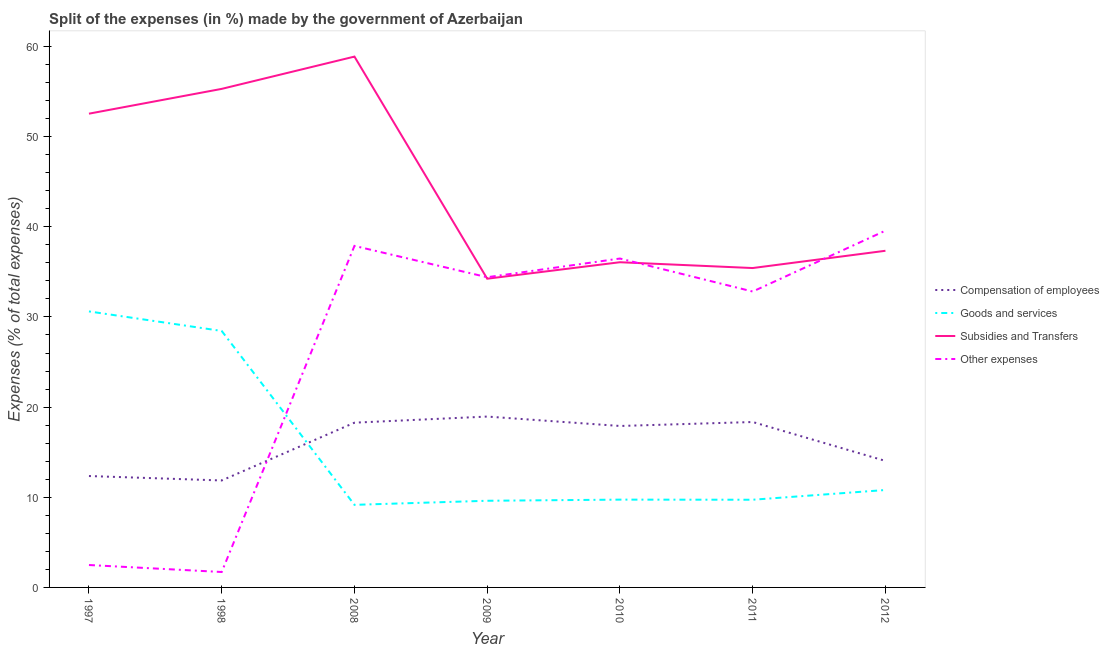How many different coloured lines are there?
Provide a succinct answer. 4. Does the line corresponding to percentage of amount spent on compensation of employees intersect with the line corresponding to percentage of amount spent on goods and services?
Provide a succinct answer. Yes. Is the number of lines equal to the number of legend labels?
Give a very brief answer. Yes. What is the percentage of amount spent on other expenses in 1997?
Offer a very short reply. 2.49. Across all years, what is the maximum percentage of amount spent on goods and services?
Offer a terse response. 30.62. Across all years, what is the minimum percentage of amount spent on goods and services?
Make the answer very short. 9.16. What is the total percentage of amount spent on other expenses in the graph?
Offer a terse response. 185.36. What is the difference between the percentage of amount spent on subsidies in 1998 and that in 2011?
Your answer should be very brief. 19.87. What is the difference between the percentage of amount spent on subsidies in 2011 and the percentage of amount spent on compensation of employees in 2012?
Keep it short and to the point. 21.39. What is the average percentage of amount spent on subsidies per year?
Give a very brief answer. 44.26. In the year 2011, what is the difference between the percentage of amount spent on goods and services and percentage of amount spent on subsidies?
Make the answer very short. -25.7. What is the ratio of the percentage of amount spent on goods and services in 2011 to that in 2012?
Your answer should be very brief. 0.9. Is the difference between the percentage of amount spent on subsidies in 1998 and 2010 greater than the difference between the percentage of amount spent on other expenses in 1998 and 2010?
Provide a succinct answer. Yes. What is the difference between the highest and the second highest percentage of amount spent on subsidies?
Offer a very short reply. 3.58. What is the difference between the highest and the lowest percentage of amount spent on subsidies?
Make the answer very short. 24.64. Is it the case that in every year, the sum of the percentage of amount spent on goods and services and percentage of amount spent on subsidies is greater than the sum of percentage of amount spent on compensation of employees and percentage of amount spent on other expenses?
Provide a succinct answer. Yes. How many lines are there?
Provide a succinct answer. 4. How many years are there in the graph?
Your response must be concise. 7. How many legend labels are there?
Your answer should be very brief. 4. How are the legend labels stacked?
Provide a short and direct response. Vertical. What is the title of the graph?
Make the answer very short. Split of the expenses (in %) made by the government of Azerbaijan. What is the label or title of the X-axis?
Provide a short and direct response. Year. What is the label or title of the Y-axis?
Keep it short and to the point. Expenses (% of total expenses). What is the Expenses (% of total expenses) of Compensation of employees in 1997?
Give a very brief answer. 12.36. What is the Expenses (% of total expenses) in Goods and services in 1997?
Offer a terse response. 30.62. What is the Expenses (% of total expenses) in Subsidies and Transfers in 1997?
Ensure brevity in your answer.  52.55. What is the Expenses (% of total expenses) in Other expenses in 1997?
Make the answer very short. 2.49. What is the Expenses (% of total expenses) in Compensation of employees in 1998?
Your answer should be very brief. 11.86. What is the Expenses (% of total expenses) in Goods and services in 1998?
Your answer should be very brief. 28.45. What is the Expenses (% of total expenses) in Subsidies and Transfers in 1998?
Your answer should be very brief. 55.3. What is the Expenses (% of total expenses) of Other expenses in 1998?
Your answer should be very brief. 1.71. What is the Expenses (% of total expenses) in Compensation of employees in 2008?
Keep it short and to the point. 18.27. What is the Expenses (% of total expenses) in Goods and services in 2008?
Keep it short and to the point. 9.16. What is the Expenses (% of total expenses) of Subsidies and Transfers in 2008?
Your answer should be compact. 58.88. What is the Expenses (% of total expenses) of Other expenses in 2008?
Offer a terse response. 37.88. What is the Expenses (% of total expenses) in Compensation of employees in 2009?
Ensure brevity in your answer.  18.95. What is the Expenses (% of total expenses) in Goods and services in 2009?
Provide a succinct answer. 9.61. What is the Expenses (% of total expenses) in Subsidies and Transfers in 2009?
Make the answer very short. 34.24. What is the Expenses (% of total expenses) of Other expenses in 2009?
Provide a succinct answer. 34.41. What is the Expenses (% of total expenses) of Compensation of employees in 2010?
Offer a terse response. 17.91. What is the Expenses (% of total expenses) in Goods and services in 2010?
Your answer should be compact. 9.74. What is the Expenses (% of total expenses) of Subsidies and Transfers in 2010?
Offer a terse response. 36.07. What is the Expenses (% of total expenses) of Other expenses in 2010?
Provide a succinct answer. 36.48. What is the Expenses (% of total expenses) in Compensation of employees in 2011?
Keep it short and to the point. 18.35. What is the Expenses (% of total expenses) in Goods and services in 2011?
Offer a very short reply. 9.73. What is the Expenses (% of total expenses) in Subsidies and Transfers in 2011?
Ensure brevity in your answer.  35.43. What is the Expenses (% of total expenses) of Other expenses in 2011?
Your answer should be compact. 32.82. What is the Expenses (% of total expenses) in Compensation of employees in 2012?
Ensure brevity in your answer.  14.03. What is the Expenses (% of total expenses) of Goods and services in 2012?
Keep it short and to the point. 10.81. What is the Expenses (% of total expenses) of Subsidies and Transfers in 2012?
Give a very brief answer. 37.34. What is the Expenses (% of total expenses) in Other expenses in 2012?
Keep it short and to the point. 39.57. Across all years, what is the maximum Expenses (% of total expenses) in Compensation of employees?
Make the answer very short. 18.95. Across all years, what is the maximum Expenses (% of total expenses) of Goods and services?
Keep it short and to the point. 30.62. Across all years, what is the maximum Expenses (% of total expenses) in Subsidies and Transfers?
Your response must be concise. 58.88. Across all years, what is the maximum Expenses (% of total expenses) in Other expenses?
Keep it short and to the point. 39.57. Across all years, what is the minimum Expenses (% of total expenses) of Compensation of employees?
Make the answer very short. 11.86. Across all years, what is the minimum Expenses (% of total expenses) in Goods and services?
Ensure brevity in your answer.  9.16. Across all years, what is the minimum Expenses (% of total expenses) of Subsidies and Transfers?
Offer a terse response. 34.24. Across all years, what is the minimum Expenses (% of total expenses) of Other expenses?
Offer a very short reply. 1.71. What is the total Expenses (% of total expenses) of Compensation of employees in the graph?
Ensure brevity in your answer.  111.74. What is the total Expenses (% of total expenses) of Goods and services in the graph?
Your response must be concise. 108.11. What is the total Expenses (% of total expenses) in Subsidies and Transfers in the graph?
Provide a succinct answer. 309.81. What is the total Expenses (% of total expenses) in Other expenses in the graph?
Your answer should be compact. 185.36. What is the difference between the Expenses (% of total expenses) of Compensation of employees in 1997 and that in 1998?
Provide a short and direct response. 0.49. What is the difference between the Expenses (% of total expenses) in Goods and services in 1997 and that in 1998?
Make the answer very short. 2.17. What is the difference between the Expenses (% of total expenses) of Subsidies and Transfers in 1997 and that in 1998?
Your response must be concise. -2.75. What is the difference between the Expenses (% of total expenses) in Other expenses in 1997 and that in 1998?
Make the answer very short. 0.77. What is the difference between the Expenses (% of total expenses) in Compensation of employees in 1997 and that in 2008?
Your answer should be compact. -5.92. What is the difference between the Expenses (% of total expenses) of Goods and services in 1997 and that in 2008?
Your answer should be compact. 21.45. What is the difference between the Expenses (% of total expenses) of Subsidies and Transfers in 1997 and that in 2008?
Provide a succinct answer. -6.33. What is the difference between the Expenses (% of total expenses) of Other expenses in 1997 and that in 2008?
Ensure brevity in your answer.  -35.4. What is the difference between the Expenses (% of total expenses) of Compensation of employees in 1997 and that in 2009?
Your response must be concise. -6.6. What is the difference between the Expenses (% of total expenses) in Goods and services in 1997 and that in 2009?
Provide a short and direct response. 21. What is the difference between the Expenses (% of total expenses) of Subsidies and Transfers in 1997 and that in 2009?
Provide a succinct answer. 18.31. What is the difference between the Expenses (% of total expenses) of Other expenses in 1997 and that in 2009?
Make the answer very short. -31.92. What is the difference between the Expenses (% of total expenses) in Compensation of employees in 1997 and that in 2010?
Your answer should be compact. -5.55. What is the difference between the Expenses (% of total expenses) in Goods and services in 1997 and that in 2010?
Give a very brief answer. 20.88. What is the difference between the Expenses (% of total expenses) in Subsidies and Transfers in 1997 and that in 2010?
Your response must be concise. 16.48. What is the difference between the Expenses (% of total expenses) of Other expenses in 1997 and that in 2010?
Offer a very short reply. -34. What is the difference between the Expenses (% of total expenses) in Compensation of employees in 1997 and that in 2011?
Offer a terse response. -5.99. What is the difference between the Expenses (% of total expenses) in Goods and services in 1997 and that in 2011?
Ensure brevity in your answer.  20.89. What is the difference between the Expenses (% of total expenses) in Subsidies and Transfers in 1997 and that in 2011?
Offer a terse response. 17.12. What is the difference between the Expenses (% of total expenses) of Other expenses in 1997 and that in 2011?
Provide a short and direct response. -30.34. What is the difference between the Expenses (% of total expenses) of Compensation of employees in 1997 and that in 2012?
Your answer should be very brief. -1.68. What is the difference between the Expenses (% of total expenses) in Goods and services in 1997 and that in 2012?
Provide a succinct answer. 19.81. What is the difference between the Expenses (% of total expenses) in Subsidies and Transfers in 1997 and that in 2012?
Keep it short and to the point. 15.21. What is the difference between the Expenses (% of total expenses) of Other expenses in 1997 and that in 2012?
Keep it short and to the point. -37.09. What is the difference between the Expenses (% of total expenses) in Compensation of employees in 1998 and that in 2008?
Your answer should be compact. -6.41. What is the difference between the Expenses (% of total expenses) of Goods and services in 1998 and that in 2008?
Provide a short and direct response. 19.29. What is the difference between the Expenses (% of total expenses) of Subsidies and Transfers in 1998 and that in 2008?
Ensure brevity in your answer.  -3.58. What is the difference between the Expenses (% of total expenses) in Other expenses in 1998 and that in 2008?
Provide a succinct answer. -36.17. What is the difference between the Expenses (% of total expenses) in Compensation of employees in 1998 and that in 2009?
Your response must be concise. -7.09. What is the difference between the Expenses (% of total expenses) in Goods and services in 1998 and that in 2009?
Ensure brevity in your answer.  18.84. What is the difference between the Expenses (% of total expenses) in Subsidies and Transfers in 1998 and that in 2009?
Your response must be concise. 21.06. What is the difference between the Expenses (% of total expenses) in Other expenses in 1998 and that in 2009?
Keep it short and to the point. -32.7. What is the difference between the Expenses (% of total expenses) of Compensation of employees in 1998 and that in 2010?
Provide a short and direct response. -6.04. What is the difference between the Expenses (% of total expenses) of Goods and services in 1998 and that in 2010?
Ensure brevity in your answer.  18.71. What is the difference between the Expenses (% of total expenses) of Subsidies and Transfers in 1998 and that in 2010?
Give a very brief answer. 19.23. What is the difference between the Expenses (% of total expenses) in Other expenses in 1998 and that in 2010?
Ensure brevity in your answer.  -34.77. What is the difference between the Expenses (% of total expenses) of Compensation of employees in 1998 and that in 2011?
Offer a terse response. -6.48. What is the difference between the Expenses (% of total expenses) of Goods and services in 1998 and that in 2011?
Provide a succinct answer. 18.72. What is the difference between the Expenses (% of total expenses) in Subsidies and Transfers in 1998 and that in 2011?
Your response must be concise. 19.87. What is the difference between the Expenses (% of total expenses) of Other expenses in 1998 and that in 2011?
Your answer should be very brief. -31.11. What is the difference between the Expenses (% of total expenses) of Compensation of employees in 1998 and that in 2012?
Keep it short and to the point. -2.17. What is the difference between the Expenses (% of total expenses) in Goods and services in 1998 and that in 2012?
Your answer should be compact. 17.64. What is the difference between the Expenses (% of total expenses) in Subsidies and Transfers in 1998 and that in 2012?
Offer a terse response. 17.96. What is the difference between the Expenses (% of total expenses) of Other expenses in 1998 and that in 2012?
Your answer should be compact. -37.86. What is the difference between the Expenses (% of total expenses) in Compensation of employees in 2008 and that in 2009?
Keep it short and to the point. -0.68. What is the difference between the Expenses (% of total expenses) in Goods and services in 2008 and that in 2009?
Give a very brief answer. -0.45. What is the difference between the Expenses (% of total expenses) in Subsidies and Transfers in 2008 and that in 2009?
Offer a terse response. 24.64. What is the difference between the Expenses (% of total expenses) in Other expenses in 2008 and that in 2009?
Your response must be concise. 3.48. What is the difference between the Expenses (% of total expenses) in Compensation of employees in 2008 and that in 2010?
Offer a very short reply. 0.37. What is the difference between the Expenses (% of total expenses) of Goods and services in 2008 and that in 2010?
Provide a short and direct response. -0.58. What is the difference between the Expenses (% of total expenses) of Subsidies and Transfers in 2008 and that in 2010?
Make the answer very short. 22.81. What is the difference between the Expenses (% of total expenses) of Other expenses in 2008 and that in 2010?
Offer a terse response. 1.4. What is the difference between the Expenses (% of total expenses) of Compensation of employees in 2008 and that in 2011?
Offer a very short reply. -0.07. What is the difference between the Expenses (% of total expenses) of Goods and services in 2008 and that in 2011?
Ensure brevity in your answer.  -0.57. What is the difference between the Expenses (% of total expenses) in Subsidies and Transfers in 2008 and that in 2011?
Keep it short and to the point. 23.45. What is the difference between the Expenses (% of total expenses) in Other expenses in 2008 and that in 2011?
Offer a very short reply. 5.06. What is the difference between the Expenses (% of total expenses) of Compensation of employees in 2008 and that in 2012?
Keep it short and to the point. 4.24. What is the difference between the Expenses (% of total expenses) of Goods and services in 2008 and that in 2012?
Your answer should be very brief. -1.65. What is the difference between the Expenses (% of total expenses) of Subsidies and Transfers in 2008 and that in 2012?
Provide a short and direct response. 21.54. What is the difference between the Expenses (% of total expenses) of Other expenses in 2008 and that in 2012?
Your response must be concise. -1.69. What is the difference between the Expenses (% of total expenses) in Compensation of employees in 2009 and that in 2010?
Provide a short and direct response. 1.04. What is the difference between the Expenses (% of total expenses) of Goods and services in 2009 and that in 2010?
Offer a terse response. -0.13. What is the difference between the Expenses (% of total expenses) of Subsidies and Transfers in 2009 and that in 2010?
Your answer should be compact. -1.83. What is the difference between the Expenses (% of total expenses) of Other expenses in 2009 and that in 2010?
Provide a succinct answer. -2.07. What is the difference between the Expenses (% of total expenses) of Compensation of employees in 2009 and that in 2011?
Provide a short and direct response. 0.6. What is the difference between the Expenses (% of total expenses) of Goods and services in 2009 and that in 2011?
Provide a short and direct response. -0.11. What is the difference between the Expenses (% of total expenses) of Subsidies and Transfers in 2009 and that in 2011?
Provide a succinct answer. -1.18. What is the difference between the Expenses (% of total expenses) of Other expenses in 2009 and that in 2011?
Your answer should be very brief. 1.59. What is the difference between the Expenses (% of total expenses) of Compensation of employees in 2009 and that in 2012?
Keep it short and to the point. 4.92. What is the difference between the Expenses (% of total expenses) in Goods and services in 2009 and that in 2012?
Offer a terse response. -1.19. What is the difference between the Expenses (% of total expenses) in Subsidies and Transfers in 2009 and that in 2012?
Your response must be concise. -3.1. What is the difference between the Expenses (% of total expenses) in Other expenses in 2009 and that in 2012?
Provide a short and direct response. -5.17. What is the difference between the Expenses (% of total expenses) of Compensation of employees in 2010 and that in 2011?
Give a very brief answer. -0.44. What is the difference between the Expenses (% of total expenses) of Goods and services in 2010 and that in 2011?
Offer a very short reply. 0.01. What is the difference between the Expenses (% of total expenses) in Subsidies and Transfers in 2010 and that in 2011?
Ensure brevity in your answer.  0.64. What is the difference between the Expenses (% of total expenses) of Other expenses in 2010 and that in 2011?
Your answer should be compact. 3.66. What is the difference between the Expenses (% of total expenses) in Compensation of employees in 2010 and that in 2012?
Give a very brief answer. 3.87. What is the difference between the Expenses (% of total expenses) in Goods and services in 2010 and that in 2012?
Make the answer very short. -1.07. What is the difference between the Expenses (% of total expenses) of Subsidies and Transfers in 2010 and that in 2012?
Ensure brevity in your answer.  -1.27. What is the difference between the Expenses (% of total expenses) in Other expenses in 2010 and that in 2012?
Your answer should be very brief. -3.09. What is the difference between the Expenses (% of total expenses) of Compensation of employees in 2011 and that in 2012?
Offer a very short reply. 4.31. What is the difference between the Expenses (% of total expenses) of Goods and services in 2011 and that in 2012?
Offer a very short reply. -1.08. What is the difference between the Expenses (% of total expenses) of Subsidies and Transfers in 2011 and that in 2012?
Provide a succinct answer. -1.92. What is the difference between the Expenses (% of total expenses) in Other expenses in 2011 and that in 2012?
Provide a short and direct response. -6.75. What is the difference between the Expenses (% of total expenses) of Compensation of employees in 1997 and the Expenses (% of total expenses) of Goods and services in 1998?
Provide a succinct answer. -16.09. What is the difference between the Expenses (% of total expenses) in Compensation of employees in 1997 and the Expenses (% of total expenses) in Subsidies and Transfers in 1998?
Your answer should be compact. -42.94. What is the difference between the Expenses (% of total expenses) in Compensation of employees in 1997 and the Expenses (% of total expenses) in Other expenses in 1998?
Your answer should be very brief. 10.64. What is the difference between the Expenses (% of total expenses) in Goods and services in 1997 and the Expenses (% of total expenses) in Subsidies and Transfers in 1998?
Offer a terse response. -24.68. What is the difference between the Expenses (% of total expenses) in Goods and services in 1997 and the Expenses (% of total expenses) in Other expenses in 1998?
Give a very brief answer. 28.9. What is the difference between the Expenses (% of total expenses) of Subsidies and Transfers in 1997 and the Expenses (% of total expenses) of Other expenses in 1998?
Provide a succinct answer. 50.84. What is the difference between the Expenses (% of total expenses) of Compensation of employees in 1997 and the Expenses (% of total expenses) of Goods and services in 2008?
Offer a very short reply. 3.2. What is the difference between the Expenses (% of total expenses) in Compensation of employees in 1997 and the Expenses (% of total expenses) in Subsidies and Transfers in 2008?
Provide a short and direct response. -46.52. What is the difference between the Expenses (% of total expenses) of Compensation of employees in 1997 and the Expenses (% of total expenses) of Other expenses in 2008?
Provide a short and direct response. -25.53. What is the difference between the Expenses (% of total expenses) in Goods and services in 1997 and the Expenses (% of total expenses) in Subsidies and Transfers in 2008?
Make the answer very short. -28.26. What is the difference between the Expenses (% of total expenses) of Goods and services in 1997 and the Expenses (% of total expenses) of Other expenses in 2008?
Ensure brevity in your answer.  -7.27. What is the difference between the Expenses (% of total expenses) in Subsidies and Transfers in 1997 and the Expenses (% of total expenses) in Other expenses in 2008?
Provide a short and direct response. 14.67. What is the difference between the Expenses (% of total expenses) in Compensation of employees in 1997 and the Expenses (% of total expenses) in Goods and services in 2009?
Your answer should be compact. 2.74. What is the difference between the Expenses (% of total expenses) in Compensation of employees in 1997 and the Expenses (% of total expenses) in Subsidies and Transfers in 2009?
Your answer should be compact. -21.89. What is the difference between the Expenses (% of total expenses) of Compensation of employees in 1997 and the Expenses (% of total expenses) of Other expenses in 2009?
Your response must be concise. -22.05. What is the difference between the Expenses (% of total expenses) in Goods and services in 1997 and the Expenses (% of total expenses) in Subsidies and Transfers in 2009?
Make the answer very short. -3.63. What is the difference between the Expenses (% of total expenses) in Goods and services in 1997 and the Expenses (% of total expenses) in Other expenses in 2009?
Keep it short and to the point. -3.79. What is the difference between the Expenses (% of total expenses) of Subsidies and Transfers in 1997 and the Expenses (% of total expenses) of Other expenses in 2009?
Provide a succinct answer. 18.14. What is the difference between the Expenses (% of total expenses) of Compensation of employees in 1997 and the Expenses (% of total expenses) of Goods and services in 2010?
Offer a very short reply. 2.62. What is the difference between the Expenses (% of total expenses) in Compensation of employees in 1997 and the Expenses (% of total expenses) in Subsidies and Transfers in 2010?
Your answer should be very brief. -23.71. What is the difference between the Expenses (% of total expenses) in Compensation of employees in 1997 and the Expenses (% of total expenses) in Other expenses in 2010?
Your answer should be very brief. -24.13. What is the difference between the Expenses (% of total expenses) in Goods and services in 1997 and the Expenses (% of total expenses) in Subsidies and Transfers in 2010?
Keep it short and to the point. -5.46. What is the difference between the Expenses (% of total expenses) of Goods and services in 1997 and the Expenses (% of total expenses) of Other expenses in 2010?
Make the answer very short. -5.87. What is the difference between the Expenses (% of total expenses) in Subsidies and Transfers in 1997 and the Expenses (% of total expenses) in Other expenses in 2010?
Give a very brief answer. 16.07. What is the difference between the Expenses (% of total expenses) of Compensation of employees in 1997 and the Expenses (% of total expenses) of Goods and services in 2011?
Your answer should be very brief. 2.63. What is the difference between the Expenses (% of total expenses) in Compensation of employees in 1997 and the Expenses (% of total expenses) in Subsidies and Transfers in 2011?
Provide a short and direct response. -23.07. What is the difference between the Expenses (% of total expenses) of Compensation of employees in 1997 and the Expenses (% of total expenses) of Other expenses in 2011?
Your response must be concise. -20.47. What is the difference between the Expenses (% of total expenses) of Goods and services in 1997 and the Expenses (% of total expenses) of Subsidies and Transfers in 2011?
Offer a very short reply. -4.81. What is the difference between the Expenses (% of total expenses) of Goods and services in 1997 and the Expenses (% of total expenses) of Other expenses in 2011?
Offer a very short reply. -2.21. What is the difference between the Expenses (% of total expenses) in Subsidies and Transfers in 1997 and the Expenses (% of total expenses) in Other expenses in 2011?
Your response must be concise. 19.73. What is the difference between the Expenses (% of total expenses) in Compensation of employees in 1997 and the Expenses (% of total expenses) in Goods and services in 2012?
Your response must be concise. 1.55. What is the difference between the Expenses (% of total expenses) in Compensation of employees in 1997 and the Expenses (% of total expenses) in Subsidies and Transfers in 2012?
Provide a succinct answer. -24.99. What is the difference between the Expenses (% of total expenses) in Compensation of employees in 1997 and the Expenses (% of total expenses) in Other expenses in 2012?
Ensure brevity in your answer.  -27.22. What is the difference between the Expenses (% of total expenses) of Goods and services in 1997 and the Expenses (% of total expenses) of Subsidies and Transfers in 2012?
Ensure brevity in your answer.  -6.73. What is the difference between the Expenses (% of total expenses) of Goods and services in 1997 and the Expenses (% of total expenses) of Other expenses in 2012?
Ensure brevity in your answer.  -8.96. What is the difference between the Expenses (% of total expenses) in Subsidies and Transfers in 1997 and the Expenses (% of total expenses) in Other expenses in 2012?
Give a very brief answer. 12.98. What is the difference between the Expenses (% of total expenses) of Compensation of employees in 1998 and the Expenses (% of total expenses) of Goods and services in 2008?
Your answer should be compact. 2.7. What is the difference between the Expenses (% of total expenses) in Compensation of employees in 1998 and the Expenses (% of total expenses) in Subsidies and Transfers in 2008?
Make the answer very short. -47.02. What is the difference between the Expenses (% of total expenses) of Compensation of employees in 1998 and the Expenses (% of total expenses) of Other expenses in 2008?
Your response must be concise. -26.02. What is the difference between the Expenses (% of total expenses) in Goods and services in 1998 and the Expenses (% of total expenses) in Subsidies and Transfers in 2008?
Your response must be concise. -30.43. What is the difference between the Expenses (% of total expenses) of Goods and services in 1998 and the Expenses (% of total expenses) of Other expenses in 2008?
Your response must be concise. -9.43. What is the difference between the Expenses (% of total expenses) of Subsidies and Transfers in 1998 and the Expenses (% of total expenses) of Other expenses in 2008?
Keep it short and to the point. 17.42. What is the difference between the Expenses (% of total expenses) in Compensation of employees in 1998 and the Expenses (% of total expenses) in Goods and services in 2009?
Ensure brevity in your answer.  2.25. What is the difference between the Expenses (% of total expenses) in Compensation of employees in 1998 and the Expenses (% of total expenses) in Subsidies and Transfers in 2009?
Provide a succinct answer. -22.38. What is the difference between the Expenses (% of total expenses) in Compensation of employees in 1998 and the Expenses (% of total expenses) in Other expenses in 2009?
Provide a short and direct response. -22.54. What is the difference between the Expenses (% of total expenses) of Goods and services in 1998 and the Expenses (% of total expenses) of Subsidies and Transfers in 2009?
Give a very brief answer. -5.79. What is the difference between the Expenses (% of total expenses) in Goods and services in 1998 and the Expenses (% of total expenses) in Other expenses in 2009?
Your response must be concise. -5.96. What is the difference between the Expenses (% of total expenses) of Subsidies and Transfers in 1998 and the Expenses (% of total expenses) of Other expenses in 2009?
Your answer should be very brief. 20.89. What is the difference between the Expenses (% of total expenses) in Compensation of employees in 1998 and the Expenses (% of total expenses) in Goods and services in 2010?
Keep it short and to the point. 2.13. What is the difference between the Expenses (% of total expenses) of Compensation of employees in 1998 and the Expenses (% of total expenses) of Subsidies and Transfers in 2010?
Keep it short and to the point. -24.21. What is the difference between the Expenses (% of total expenses) in Compensation of employees in 1998 and the Expenses (% of total expenses) in Other expenses in 2010?
Keep it short and to the point. -24.62. What is the difference between the Expenses (% of total expenses) in Goods and services in 1998 and the Expenses (% of total expenses) in Subsidies and Transfers in 2010?
Provide a succinct answer. -7.62. What is the difference between the Expenses (% of total expenses) in Goods and services in 1998 and the Expenses (% of total expenses) in Other expenses in 2010?
Give a very brief answer. -8.03. What is the difference between the Expenses (% of total expenses) in Subsidies and Transfers in 1998 and the Expenses (% of total expenses) in Other expenses in 2010?
Your answer should be very brief. 18.82. What is the difference between the Expenses (% of total expenses) of Compensation of employees in 1998 and the Expenses (% of total expenses) of Goods and services in 2011?
Give a very brief answer. 2.14. What is the difference between the Expenses (% of total expenses) of Compensation of employees in 1998 and the Expenses (% of total expenses) of Subsidies and Transfers in 2011?
Your answer should be very brief. -23.56. What is the difference between the Expenses (% of total expenses) in Compensation of employees in 1998 and the Expenses (% of total expenses) in Other expenses in 2011?
Ensure brevity in your answer.  -20.96. What is the difference between the Expenses (% of total expenses) in Goods and services in 1998 and the Expenses (% of total expenses) in Subsidies and Transfers in 2011?
Make the answer very short. -6.98. What is the difference between the Expenses (% of total expenses) of Goods and services in 1998 and the Expenses (% of total expenses) of Other expenses in 2011?
Provide a short and direct response. -4.37. What is the difference between the Expenses (% of total expenses) in Subsidies and Transfers in 1998 and the Expenses (% of total expenses) in Other expenses in 2011?
Provide a succinct answer. 22.48. What is the difference between the Expenses (% of total expenses) of Compensation of employees in 1998 and the Expenses (% of total expenses) of Goods and services in 2012?
Provide a succinct answer. 1.06. What is the difference between the Expenses (% of total expenses) in Compensation of employees in 1998 and the Expenses (% of total expenses) in Subsidies and Transfers in 2012?
Ensure brevity in your answer.  -25.48. What is the difference between the Expenses (% of total expenses) of Compensation of employees in 1998 and the Expenses (% of total expenses) of Other expenses in 2012?
Your response must be concise. -27.71. What is the difference between the Expenses (% of total expenses) in Goods and services in 1998 and the Expenses (% of total expenses) in Subsidies and Transfers in 2012?
Your response must be concise. -8.89. What is the difference between the Expenses (% of total expenses) of Goods and services in 1998 and the Expenses (% of total expenses) of Other expenses in 2012?
Give a very brief answer. -11.12. What is the difference between the Expenses (% of total expenses) of Subsidies and Transfers in 1998 and the Expenses (% of total expenses) of Other expenses in 2012?
Keep it short and to the point. 15.73. What is the difference between the Expenses (% of total expenses) in Compensation of employees in 2008 and the Expenses (% of total expenses) in Goods and services in 2009?
Ensure brevity in your answer.  8.66. What is the difference between the Expenses (% of total expenses) of Compensation of employees in 2008 and the Expenses (% of total expenses) of Subsidies and Transfers in 2009?
Ensure brevity in your answer.  -15.97. What is the difference between the Expenses (% of total expenses) in Compensation of employees in 2008 and the Expenses (% of total expenses) in Other expenses in 2009?
Provide a succinct answer. -16.13. What is the difference between the Expenses (% of total expenses) in Goods and services in 2008 and the Expenses (% of total expenses) in Subsidies and Transfers in 2009?
Provide a short and direct response. -25.08. What is the difference between the Expenses (% of total expenses) of Goods and services in 2008 and the Expenses (% of total expenses) of Other expenses in 2009?
Provide a succinct answer. -25.25. What is the difference between the Expenses (% of total expenses) in Subsidies and Transfers in 2008 and the Expenses (% of total expenses) in Other expenses in 2009?
Provide a succinct answer. 24.47. What is the difference between the Expenses (% of total expenses) of Compensation of employees in 2008 and the Expenses (% of total expenses) of Goods and services in 2010?
Offer a very short reply. 8.54. What is the difference between the Expenses (% of total expenses) of Compensation of employees in 2008 and the Expenses (% of total expenses) of Subsidies and Transfers in 2010?
Your answer should be very brief. -17.8. What is the difference between the Expenses (% of total expenses) of Compensation of employees in 2008 and the Expenses (% of total expenses) of Other expenses in 2010?
Your response must be concise. -18.21. What is the difference between the Expenses (% of total expenses) of Goods and services in 2008 and the Expenses (% of total expenses) of Subsidies and Transfers in 2010?
Your response must be concise. -26.91. What is the difference between the Expenses (% of total expenses) of Goods and services in 2008 and the Expenses (% of total expenses) of Other expenses in 2010?
Your response must be concise. -27.32. What is the difference between the Expenses (% of total expenses) in Subsidies and Transfers in 2008 and the Expenses (% of total expenses) in Other expenses in 2010?
Offer a terse response. 22.4. What is the difference between the Expenses (% of total expenses) in Compensation of employees in 2008 and the Expenses (% of total expenses) in Goods and services in 2011?
Provide a succinct answer. 8.55. What is the difference between the Expenses (% of total expenses) of Compensation of employees in 2008 and the Expenses (% of total expenses) of Subsidies and Transfers in 2011?
Ensure brevity in your answer.  -17.15. What is the difference between the Expenses (% of total expenses) in Compensation of employees in 2008 and the Expenses (% of total expenses) in Other expenses in 2011?
Keep it short and to the point. -14.55. What is the difference between the Expenses (% of total expenses) of Goods and services in 2008 and the Expenses (% of total expenses) of Subsidies and Transfers in 2011?
Provide a short and direct response. -26.27. What is the difference between the Expenses (% of total expenses) of Goods and services in 2008 and the Expenses (% of total expenses) of Other expenses in 2011?
Offer a terse response. -23.66. What is the difference between the Expenses (% of total expenses) in Subsidies and Transfers in 2008 and the Expenses (% of total expenses) in Other expenses in 2011?
Give a very brief answer. 26.06. What is the difference between the Expenses (% of total expenses) in Compensation of employees in 2008 and the Expenses (% of total expenses) in Goods and services in 2012?
Keep it short and to the point. 7.47. What is the difference between the Expenses (% of total expenses) in Compensation of employees in 2008 and the Expenses (% of total expenses) in Subsidies and Transfers in 2012?
Provide a succinct answer. -19.07. What is the difference between the Expenses (% of total expenses) in Compensation of employees in 2008 and the Expenses (% of total expenses) in Other expenses in 2012?
Make the answer very short. -21.3. What is the difference between the Expenses (% of total expenses) of Goods and services in 2008 and the Expenses (% of total expenses) of Subsidies and Transfers in 2012?
Keep it short and to the point. -28.18. What is the difference between the Expenses (% of total expenses) of Goods and services in 2008 and the Expenses (% of total expenses) of Other expenses in 2012?
Give a very brief answer. -30.41. What is the difference between the Expenses (% of total expenses) in Subsidies and Transfers in 2008 and the Expenses (% of total expenses) in Other expenses in 2012?
Provide a succinct answer. 19.31. What is the difference between the Expenses (% of total expenses) in Compensation of employees in 2009 and the Expenses (% of total expenses) in Goods and services in 2010?
Offer a very short reply. 9.21. What is the difference between the Expenses (% of total expenses) of Compensation of employees in 2009 and the Expenses (% of total expenses) of Subsidies and Transfers in 2010?
Keep it short and to the point. -17.12. What is the difference between the Expenses (% of total expenses) in Compensation of employees in 2009 and the Expenses (% of total expenses) in Other expenses in 2010?
Offer a terse response. -17.53. What is the difference between the Expenses (% of total expenses) of Goods and services in 2009 and the Expenses (% of total expenses) of Subsidies and Transfers in 2010?
Ensure brevity in your answer.  -26.46. What is the difference between the Expenses (% of total expenses) in Goods and services in 2009 and the Expenses (% of total expenses) in Other expenses in 2010?
Give a very brief answer. -26.87. What is the difference between the Expenses (% of total expenses) of Subsidies and Transfers in 2009 and the Expenses (% of total expenses) of Other expenses in 2010?
Provide a short and direct response. -2.24. What is the difference between the Expenses (% of total expenses) of Compensation of employees in 2009 and the Expenses (% of total expenses) of Goods and services in 2011?
Provide a short and direct response. 9.23. What is the difference between the Expenses (% of total expenses) in Compensation of employees in 2009 and the Expenses (% of total expenses) in Subsidies and Transfers in 2011?
Offer a very short reply. -16.47. What is the difference between the Expenses (% of total expenses) of Compensation of employees in 2009 and the Expenses (% of total expenses) of Other expenses in 2011?
Keep it short and to the point. -13.87. What is the difference between the Expenses (% of total expenses) of Goods and services in 2009 and the Expenses (% of total expenses) of Subsidies and Transfers in 2011?
Provide a succinct answer. -25.81. What is the difference between the Expenses (% of total expenses) in Goods and services in 2009 and the Expenses (% of total expenses) in Other expenses in 2011?
Your answer should be compact. -23.21. What is the difference between the Expenses (% of total expenses) of Subsidies and Transfers in 2009 and the Expenses (% of total expenses) of Other expenses in 2011?
Provide a succinct answer. 1.42. What is the difference between the Expenses (% of total expenses) of Compensation of employees in 2009 and the Expenses (% of total expenses) of Goods and services in 2012?
Ensure brevity in your answer.  8.15. What is the difference between the Expenses (% of total expenses) of Compensation of employees in 2009 and the Expenses (% of total expenses) of Subsidies and Transfers in 2012?
Offer a terse response. -18.39. What is the difference between the Expenses (% of total expenses) of Compensation of employees in 2009 and the Expenses (% of total expenses) of Other expenses in 2012?
Give a very brief answer. -20.62. What is the difference between the Expenses (% of total expenses) in Goods and services in 2009 and the Expenses (% of total expenses) in Subsidies and Transfers in 2012?
Offer a terse response. -27.73. What is the difference between the Expenses (% of total expenses) of Goods and services in 2009 and the Expenses (% of total expenses) of Other expenses in 2012?
Provide a succinct answer. -29.96. What is the difference between the Expenses (% of total expenses) in Subsidies and Transfers in 2009 and the Expenses (% of total expenses) in Other expenses in 2012?
Your response must be concise. -5.33. What is the difference between the Expenses (% of total expenses) of Compensation of employees in 2010 and the Expenses (% of total expenses) of Goods and services in 2011?
Make the answer very short. 8.18. What is the difference between the Expenses (% of total expenses) in Compensation of employees in 2010 and the Expenses (% of total expenses) in Subsidies and Transfers in 2011?
Give a very brief answer. -17.52. What is the difference between the Expenses (% of total expenses) of Compensation of employees in 2010 and the Expenses (% of total expenses) of Other expenses in 2011?
Offer a very short reply. -14.91. What is the difference between the Expenses (% of total expenses) of Goods and services in 2010 and the Expenses (% of total expenses) of Subsidies and Transfers in 2011?
Offer a very short reply. -25.69. What is the difference between the Expenses (% of total expenses) in Goods and services in 2010 and the Expenses (% of total expenses) in Other expenses in 2011?
Ensure brevity in your answer.  -23.08. What is the difference between the Expenses (% of total expenses) in Subsidies and Transfers in 2010 and the Expenses (% of total expenses) in Other expenses in 2011?
Give a very brief answer. 3.25. What is the difference between the Expenses (% of total expenses) in Compensation of employees in 2010 and the Expenses (% of total expenses) in Goods and services in 2012?
Keep it short and to the point. 7.1. What is the difference between the Expenses (% of total expenses) in Compensation of employees in 2010 and the Expenses (% of total expenses) in Subsidies and Transfers in 2012?
Provide a short and direct response. -19.43. What is the difference between the Expenses (% of total expenses) of Compensation of employees in 2010 and the Expenses (% of total expenses) of Other expenses in 2012?
Provide a short and direct response. -21.66. What is the difference between the Expenses (% of total expenses) in Goods and services in 2010 and the Expenses (% of total expenses) in Subsidies and Transfers in 2012?
Offer a terse response. -27.6. What is the difference between the Expenses (% of total expenses) of Goods and services in 2010 and the Expenses (% of total expenses) of Other expenses in 2012?
Your answer should be compact. -29.83. What is the difference between the Expenses (% of total expenses) of Subsidies and Transfers in 2010 and the Expenses (% of total expenses) of Other expenses in 2012?
Your response must be concise. -3.5. What is the difference between the Expenses (% of total expenses) of Compensation of employees in 2011 and the Expenses (% of total expenses) of Goods and services in 2012?
Keep it short and to the point. 7.54. What is the difference between the Expenses (% of total expenses) in Compensation of employees in 2011 and the Expenses (% of total expenses) in Subsidies and Transfers in 2012?
Your response must be concise. -18.99. What is the difference between the Expenses (% of total expenses) of Compensation of employees in 2011 and the Expenses (% of total expenses) of Other expenses in 2012?
Give a very brief answer. -21.22. What is the difference between the Expenses (% of total expenses) in Goods and services in 2011 and the Expenses (% of total expenses) in Subsidies and Transfers in 2012?
Keep it short and to the point. -27.61. What is the difference between the Expenses (% of total expenses) in Goods and services in 2011 and the Expenses (% of total expenses) in Other expenses in 2012?
Offer a terse response. -29.85. What is the difference between the Expenses (% of total expenses) in Subsidies and Transfers in 2011 and the Expenses (% of total expenses) in Other expenses in 2012?
Keep it short and to the point. -4.15. What is the average Expenses (% of total expenses) of Compensation of employees per year?
Your answer should be compact. 15.96. What is the average Expenses (% of total expenses) of Goods and services per year?
Provide a succinct answer. 15.44. What is the average Expenses (% of total expenses) of Subsidies and Transfers per year?
Keep it short and to the point. 44.26. What is the average Expenses (% of total expenses) in Other expenses per year?
Offer a terse response. 26.48. In the year 1997, what is the difference between the Expenses (% of total expenses) of Compensation of employees and Expenses (% of total expenses) of Goods and services?
Offer a terse response. -18.26. In the year 1997, what is the difference between the Expenses (% of total expenses) in Compensation of employees and Expenses (% of total expenses) in Subsidies and Transfers?
Ensure brevity in your answer.  -40.19. In the year 1997, what is the difference between the Expenses (% of total expenses) in Compensation of employees and Expenses (% of total expenses) in Other expenses?
Make the answer very short. 9.87. In the year 1997, what is the difference between the Expenses (% of total expenses) in Goods and services and Expenses (% of total expenses) in Subsidies and Transfers?
Ensure brevity in your answer.  -21.93. In the year 1997, what is the difference between the Expenses (% of total expenses) in Goods and services and Expenses (% of total expenses) in Other expenses?
Offer a very short reply. 28.13. In the year 1997, what is the difference between the Expenses (% of total expenses) of Subsidies and Transfers and Expenses (% of total expenses) of Other expenses?
Make the answer very short. 50.06. In the year 1998, what is the difference between the Expenses (% of total expenses) of Compensation of employees and Expenses (% of total expenses) of Goods and services?
Your answer should be very brief. -16.58. In the year 1998, what is the difference between the Expenses (% of total expenses) of Compensation of employees and Expenses (% of total expenses) of Subsidies and Transfers?
Your answer should be very brief. -43.44. In the year 1998, what is the difference between the Expenses (% of total expenses) in Compensation of employees and Expenses (% of total expenses) in Other expenses?
Give a very brief answer. 10.15. In the year 1998, what is the difference between the Expenses (% of total expenses) of Goods and services and Expenses (% of total expenses) of Subsidies and Transfers?
Your answer should be compact. -26.85. In the year 1998, what is the difference between the Expenses (% of total expenses) of Goods and services and Expenses (% of total expenses) of Other expenses?
Keep it short and to the point. 26.74. In the year 1998, what is the difference between the Expenses (% of total expenses) of Subsidies and Transfers and Expenses (% of total expenses) of Other expenses?
Provide a succinct answer. 53.59. In the year 2008, what is the difference between the Expenses (% of total expenses) in Compensation of employees and Expenses (% of total expenses) in Goods and services?
Keep it short and to the point. 9.11. In the year 2008, what is the difference between the Expenses (% of total expenses) in Compensation of employees and Expenses (% of total expenses) in Subsidies and Transfers?
Your answer should be very brief. -40.61. In the year 2008, what is the difference between the Expenses (% of total expenses) in Compensation of employees and Expenses (% of total expenses) in Other expenses?
Offer a terse response. -19.61. In the year 2008, what is the difference between the Expenses (% of total expenses) of Goods and services and Expenses (% of total expenses) of Subsidies and Transfers?
Provide a short and direct response. -49.72. In the year 2008, what is the difference between the Expenses (% of total expenses) in Goods and services and Expenses (% of total expenses) in Other expenses?
Provide a succinct answer. -28.72. In the year 2008, what is the difference between the Expenses (% of total expenses) of Subsidies and Transfers and Expenses (% of total expenses) of Other expenses?
Provide a succinct answer. 21. In the year 2009, what is the difference between the Expenses (% of total expenses) of Compensation of employees and Expenses (% of total expenses) of Goods and services?
Offer a terse response. 9.34. In the year 2009, what is the difference between the Expenses (% of total expenses) in Compensation of employees and Expenses (% of total expenses) in Subsidies and Transfers?
Your response must be concise. -15.29. In the year 2009, what is the difference between the Expenses (% of total expenses) of Compensation of employees and Expenses (% of total expenses) of Other expenses?
Make the answer very short. -15.45. In the year 2009, what is the difference between the Expenses (% of total expenses) in Goods and services and Expenses (% of total expenses) in Subsidies and Transfers?
Keep it short and to the point. -24.63. In the year 2009, what is the difference between the Expenses (% of total expenses) in Goods and services and Expenses (% of total expenses) in Other expenses?
Keep it short and to the point. -24.79. In the year 2009, what is the difference between the Expenses (% of total expenses) in Subsidies and Transfers and Expenses (% of total expenses) in Other expenses?
Make the answer very short. -0.16. In the year 2010, what is the difference between the Expenses (% of total expenses) of Compensation of employees and Expenses (% of total expenses) of Goods and services?
Give a very brief answer. 8.17. In the year 2010, what is the difference between the Expenses (% of total expenses) in Compensation of employees and Expenses (% of total expenses) in Subsidies and Transfers?
Offer a very short reply. -18.16. In the year 2010, what is the difference between the Expenses (% of total expenses) of Compensation of employees and Expenses (% of total expenses) of Other expenses?
Give a very brief answer. -18.57. In the year 2010, what is the difference between the Expenses (% of total expenses) in Goods and services and Expenses (% of total expenses) in Subsidies and Transfers?
Offer a terse response. -26.33. In the year 2010, what is the difference between the Expenses (% of total expenses) of Goods and services and Expenses (% of total expenses) of Other expenses?
Offer a very short reply. -26.74. In the year 2010, what is the difference between the Expenses (% of total expenses) of Subsidies and Transfers and Expenses (% of total expenses) of Other expenses?
Your response must be concise. -0.41. In the year 2011, what is the difference between the Expenses (% of total expenses) of Compensation of employees and Expenses (% of total expenses) of Goods and services?
Make the answer very short. 8.62. In the year 2011, what is the difference between the Expenses (% of total expenses) of Compensation of employees and Expenses (% of total expenses) of Subsidies and Transfers?
Your answer should be very brief. -17.08. In the year 2011, what is the difference between the Expenses (% of total expenses) of Compensation of employees and Expenses (% of total expenses) of Other expenses?
Your answer should be very brief. -14.47. In the year 2011, what is the difference between the Expenses (% of total expenses) of Goods and services and Expenses (% of total expenses) of Subsidies and Transfers?
Ensure brevity in your answer.  -25.7. In the year 2011, what is the difference between the Expenses (% of total expenses) of Goods and services and Expenses (% of total expenses) of Other expenses?
Ensure brevity in your answer.  -23.09. In the year 2011, what is the difference between the Expenses (% of total expenses) of Subsidies and Transfers and Expenses (% of total expenses) of Other expenses?
Provide a succinct answer. 2.6. In the year 2012, what is the difference between the Expenses (% of total expenses) in Compensation of employees and Expenses (% of total expenses) in Goods and services?
Offer a terse response. 3.23. In the year 2012, what is the difference between the Expenses (% of total expenses) in Compensation of employees and Expenses (% of total expenses) in Subsidies and Transfers?
Your answer should be very brief. -23.31. In the year 2012, what is the difference between the Expenses (% of total expenses) of Compensation of employees and Expenses (% of total expenses) of Other expenses?
Your answer should be very brief. -25.54. In the year 2012, what is the difference between the Expenses (% of total expenses) of Goods and services and Expenses (% of total expenses) of Subsidies and Transfers?
Provide a short and direct response. -26.53. In the year 2012, what is the difference between the Expenses (% of total expenses) in Goods and services and Expenses (% of total expenses) in Other expenses?
Make the answer very short. -28.77. In the year 2012, what is the difference between the Expenses (% of total expenses) in Subsidies and Transfers and Expenses (% of total expenses) in Other expenses?
Offer a terse response. -2.23. What is the ratio of the Expenses (% of total expenses) in Compensation of employees in 1997 to that in 1998?
Give a very brief answer. 1.04. What is the ratio of the Expenses (% of total expenses) in Goods and services in 1997 to that in 1998?
Provide a succinct answer. 1.08. What is the ratio of the Expenses (% of total expenses) of Subsidies and Transfers in 1997 to that in 1998?
Ensure brevity in your answer.  0.95. What is the ratio of the Expenses (% of total expenses) of Other expenses in 1997 to that in 1998?
Your answer should be compact. 1.45. What is the ratio of the Expenses (% of total expenses) in Compensation of employees in 1997 to that in 2008?
Offer a very short reply. 0.68. What is the ratio of the Expenses (% of total expenses) of Goods and services in 1997 to that in 2008?
Your response must be concise. 3.34. What is the ratio of the Expenses (% of total expenses) in Subsidies and Transfers in 1997 to that in 2008?
Offer a terse response. 0.89. What is the ratio of the Expenses (% of total expenses) in Other expenses in 1997 to that in 2008?
Provide a succinct answer. 0.07. What is the ratio of the Expenses (% of total expenses) of Compensation of employees in 1997 to that in 2009?
Offer a terse response. 0.65. What is the ratio of the Expenses (% of total expenses) of Goods and services in 1997 to that in 2009?
Give a very brief answer. 3.19. What is the ratio of the Expenses (% of total expenses) of Subsidies and Transfers in 1997 to that in 2009?
Your response must be concise. 1.53. What is the ratio of the Expenses (% of total expenses) of Other expenses in 1997 to that in 2009?
Ensure brevity in your answer.  0.07. What is the ratio of the Expenses (% of total expenses) in Compensation of employees in 1997 to that in 2010?
Offer a very short reply. 0.69. What is the ratio of the Expenses (% of total expenses) in Goods and services in 1997 to that in 2010?
Your answer should be compact. 3.14. What is the ratio of the Expenses (% of total expenses) of Subsidies and Transfers in 1997 to that in 2010?
Your answer should be compact. 1.46. What is the ratio of the Expenses (% of total expenses) in Other expenses in 1997 to that in 2010?
Keep it short and to the point. 0.07. What is the ratio of the Expenses (% of total expenses) in Compensation of employees in 1997 to that in 2011?
Offer a terse response. 0.67. What is the ratio of the Expenses (% of total expenses) in Goods and services in 1997 to that in 2011?
Your response must be concise. 3.15. What is the ratio of the Expenses (% of total expenses) of Subsidies and Transfers in 1997 to that in 2011?
Offer a very short reply. 1.48. What is the ratio of the Expenses (% of total expenses) in Other expenses in 1997 to that in 2011?
Your answer should be very brief. 0.08. What is the ratio of the Expenses (% of total expenses) in Compensation of employees in 1997 to that in 2012?
Offer a very short reply. 0.88. What is the ratio of the Expenses (% of total expenses) in Goods and services in 1997 to that in 2012?
Offer a very short reply. 2.83. What is the ratio of the Expenses (% of total expenses) of Subsidies and Transfers in 1997 to that in 2012?
Your answer should be compact. 1.41. What is the ratio of the Expenses (% of total expenses) in Other expenses in 1997 to that in 2012?
Give a very brief answer. 0.06. What is the ratio of the Expenses (% of total expenses) in Compensation of employees in 1998 to that in 2008?
Give a very brief answer. 0.65. What is the ratio of the Expenses (% of total expenses) of Goods and services in 1998 to that in 2008?
Give a very brief answer. 3.11. What is the ratio of the Expenses (% of total expenses) in Subsidies and Transfers in 1998 to that in 2008?
Your response must be concise. 0.94. What is the ratio of the Expenses (% of total expenses) in Other expenses in 1998 to that in 2008?
Offer a very short reply. 0.05. What is the ratio of the Expenses (% of total expenses) of Compensation of employees in 1998 to that in 2009?
Provide a short and direct response. 0.63. What is the ratio of the Expenses (% of total expenses) of Goods and services in 1998 to that in 2009?
Offer a very short reply. 2.96. What is the ratio of the Expenses (% of total expenses) in Subsidies and Transfers in 1998 to that in 2009?
Give a very brief answer. 1.61. What is the ratio of the Expenses (% of total expenses) of Other expenses in 1998 to that in 2009?
Ensure brevity in your answer.  0.05. What is the ratio of the Expenses (% of total expenses) of Compensation of employees in 1998 to that in 2010?
Give a very brief answer. 0.66. What is the ratio of the Expenses (% of total expenses) of Goods and services in 1998 to that in 2010?
Keep it short and to the point. 2.92. What is the ratio of the Expenses (% of total expenses) of Subsidies and Transfers in 1998 to that in 2010?
Provide a short and direct response. 1.53. What is the ratio of the Expenses (% of total expenses) in Other expenses in 1998 to that in 2010?
Your response must be concise. 0.05. What is the ratio of the Expenses (% of total expenses) in Compensation of employees in 1998 to that in 2011?
Keep it short and to the point. 0.65. What is the ratio of the Expenses (% of total expenses) in Goods and services in 1998 to that in 2011?
Your response must be concise. 2.92. What is the ratio of the Expenses (% of total expenses) of Subsidies and Transfers in 1998 to that in 2011?
Offer a very short reply. 1.56. What is the ratio of the Expenses (% of total expenses) of Other expenses in 1998 to that in 2011?
Offer a terse response. 0.05. What is the ratio of the Expenses (% of total expenses) in Compensation of employees in 1998 to that in 2012?
Make the answer very short. 0.85. What is the ratio of the Expenses (% of total expenses) in Goods and services in 1998 to that in 2012?
Keep it short and to the point. 2.63. What is the ratio of the Expenses (% of total expenses) in Subsidies and Transfers in 1998 to that in 2012?
Keep it short and to the point. 1.48. What is the ratio of the Expenses (% of total expenses) of Other expenses in 1998 to that in 2012?
Your answer should be compact. 0.04. What is the ratio of the Expenses (% of total expenses) in Compensation of employees in 2008 to that in 2009?
Offer a very short reply. 0.96. What is the ratio of the Expenses (% of total expenses) of Goods and services in 2008 to that in 2009?
Give a very brief answer. 0.95. What is the ratio of the Expenses (% of total expenses) in Subsidies and Transfers in 2008 to that in 2009?
Make the answer very short. 1.72. What is the ratio of the Expenses (% of total expenses) of Other expenses in 2008 to that in 2009?
Your answer should be compact. 1.1. What is the ratio of the Expenses (% of total expenses) in Compensation of employees in 2008 to that in 2010?
Your answer should be very brief. 1.02. What is the ratio of the Expenses (% of total expenses) in Goods and services in 2008 to that in 2010?
Keep it short and to the point. 0.94. What is the ratio of the Expenses (% of total expenses) in Subsidies and Transfers in 2008 to that in 2010?
Keep it short and to the point. 1.63. What is the ratio of the Expenses (% of total expenses) of Other expenses in 2008 to that in 2010?
Offer a terse response. 1.04. What is the ratio of the Expenses (% of total expenses) in Goods and services in 2008 to that in 2011?
Give a very brief answer. 0.94. What is the ratio of the Expenses (% of total expenses) of Subsidies and Transfers in 2008 to that in 2011?
Provide a succinct answer. 1.66. What is the ratio of the Expenses (% of total expenses) in Other expenses in 2008 to that in 2011?
Offer a very short reply. 1.15. What is the ratio of the Expenses (% of total expenses) in Compensation of employees in 2008 to that in 2012?
Provide a succinct answer. 1.3. What is the ratio of the Expenses (% of total expenses) of Goods and services in 2008 to that in 2012?
Your response must be concise. 0.85. What is the ratio of the Expenses (% of total expenses) in Subsidies and Transfers in 2008 to that in 2012?
Provide a succinct answer. 1.58. What is the ratio of the Expenses (% of total expenses) in Other expenses in 2008 to that in 2012?
Offer a very short reply. 0.96. What is the ratio of the Expenses (% of total expenses) of Compensation of employees in 2009 to that in 2010?
Keep it short and to the point. 1.06. What is the ratio of the Expenses (% of total expenses) of Goods and services in 2009 to that in 2010?
Give a very brief answer. 0.99. What is the ratio of the Expenses (% of total expenses) of Subsidies and Transfers in 2009 to that in 2010?
Give a very brief answer. 0.95. What is the ratio of the Expenses (% of total expenses) of Other expenses in 2009 to that in 2010?
Offer a terse response. 0.94. What is the ratio of the Expenses (% of total expenses) of Compensation of employees in 2009 to that in 2011?
Your answer should be very brief. 1.03. What is the ratio of the Expenses (% of total expenses) of Goods and services in 2009 to that in 2011?
Give a very brief answer. 0.99. What is the ratio of the Expenses (% of total expenses) in Subsidies and Transfers in 2009 to that in 2011?
Keep it short and to the point. 0.97. What is the ratio of the Expenses (% of total expenses) in Other expenses in 2009 to that in 2011?
Ensure brevity in your answer.  1.05. What is the ratio of the Expenses (% of total expenses) of Compensation of employees in 2009 to that in 2012?
Keep it short and to the point. 1.35. What is the ratio of the Expenses (% of total expenses) in Goods and services in 2009 to that in 2012?
Offer a very short reply. 0.89. What is the ratio of the Expenses (% of total expenses) of Subsidies and Transfers in 2009 to that in 2012?
Give a very brief answer. 0.92. What is the ratio of the Expenses (% of total expenses) in Other expenses in 2009 to that in 2012?
Make the answer very short. 0.87. What is the ratio of the Expenses (% of total expenses) of Subsidies and Transfers in 2010 to that in 2011?
Provide a succinct answer. 1.02. What is the ratio of the Expenses (% of total expenses) of Other expenses in 2010 to that in 2011?
Make the answer very short. 1.11. What is the ratio of the Expenses (% of total expenses) of Compensation of employees in 2010 to that in 2012?
Provide a short and direct response. 1.28. What is the ratio of the Expenses (% of total expenses) of Goods and services in 2010 to that in 2012?
Offer a very short reply. 0.9. What is the ratio of the Expenses (% of total expenses) in Subsidies and Transfers in 2010 to that in 2012?
Keep it short and to the point. 0.97. What is the ratio of the Expenses (% of total expenses) in Other expenses in 2010 to that in 2012?
Your response must be concise. 0.92. What is the ratio of the Expenses (% of total expenses) of Compensation of employees in 2011 to that in 2012?
Your answer should be compact. 1.31. What is the ratio of the Expenses (% of total expenses) in Goods and services in 2011 to that in 2012?
Your response must be concise. 0.9. What is the ratio of the Expenses (% of total expenses) in Subsidies and Transfers in 2011 to that in 2012?
Give a very brief answer. 0.95. What is the ratio of the Expenses (% of total expenses) in Other expenses in 2011 to that in 2012?
Provide a succinct answer. 0.83. What is the difference between the highest and the second highest Expenses (% of total expenses) of Compensation of employees?
Keep it short and to the point. 0.6. What is the difference between the highest and the second highest Expenses (% of total expenses) in Goods and services?
Offer a very short reply. 2.17. What is the difference between the highest and the second highest Expenses (% of total expenses) of Subsidies and Transfers?
Provide a short and direct response. 3.58. What is the difference between the highest and the second highest Expenses (% of total expenses) of Other expenses?
Offer a terse response. 1.69. What is the difference between the highest and the lowest Expenses (% of total expenses) of Compensation of employees?
Ensure brevity in your answer.  7.09. What is the difference between the highest and the lowest Expenses (% of total expenses) of Goods and services?
Ensure brevity in your answer.  21.45. What is the difference between the highest and the lowest Expenses (% of total expenses) of Subsidies and Transfers?
Offer a terse response. 24.64. What is the difference between the highest and the lowest Expenses (% of total expenses) in Other expenses?
Provide a succinct answer. 37.86. 